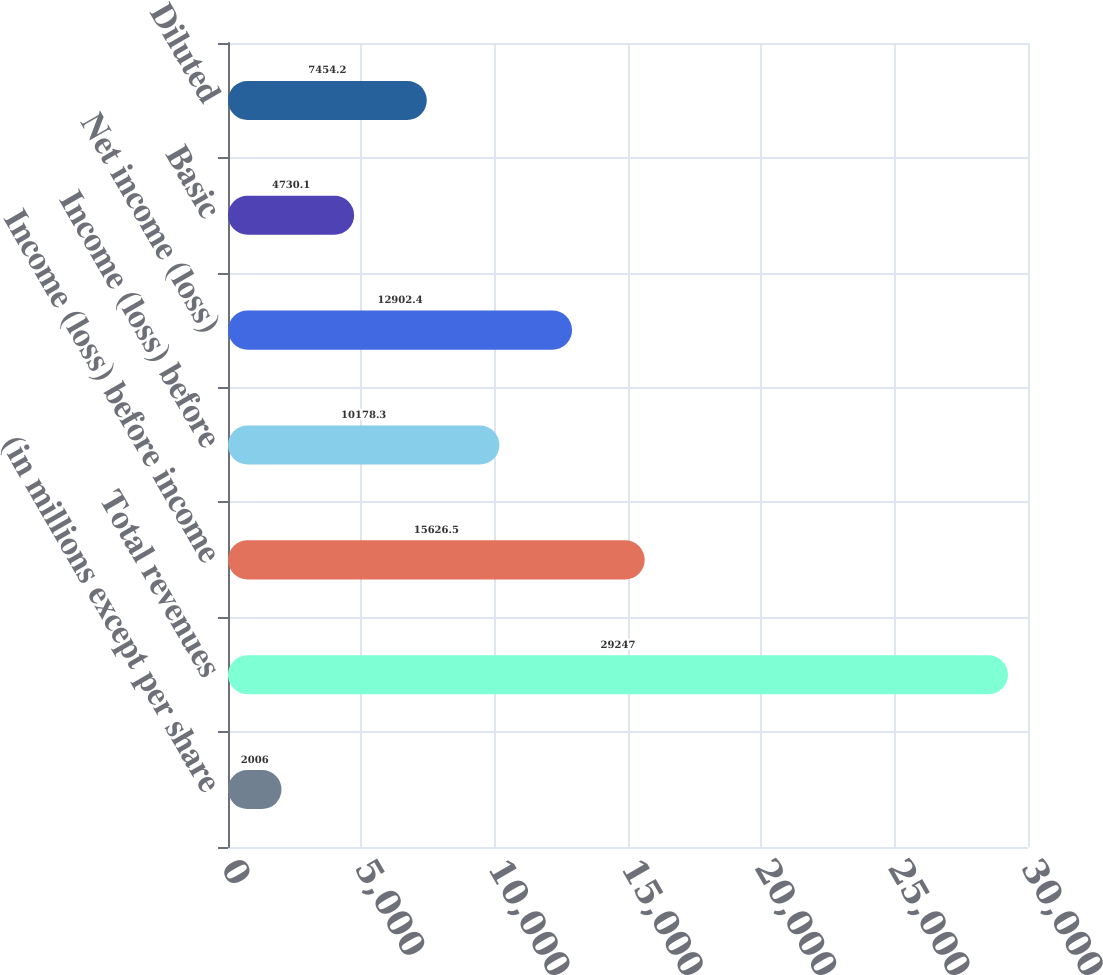<chart> <loc_0><loc_0><loc_500><loc_500><bar_chart><fcel>(in millions except per share<fcel>Total revenues<fcel>Income (loss) before income<fcel>Income (loss) before<fcel>Net income (loss)<fcel>Basic<fcel>Diluted<nl><fcel>2006<fcel>29247<fcel>15626.5<fcel>10178.3<fcel>12902.4<fcel>4730.1<fcel>7454.2<nl></chart> 